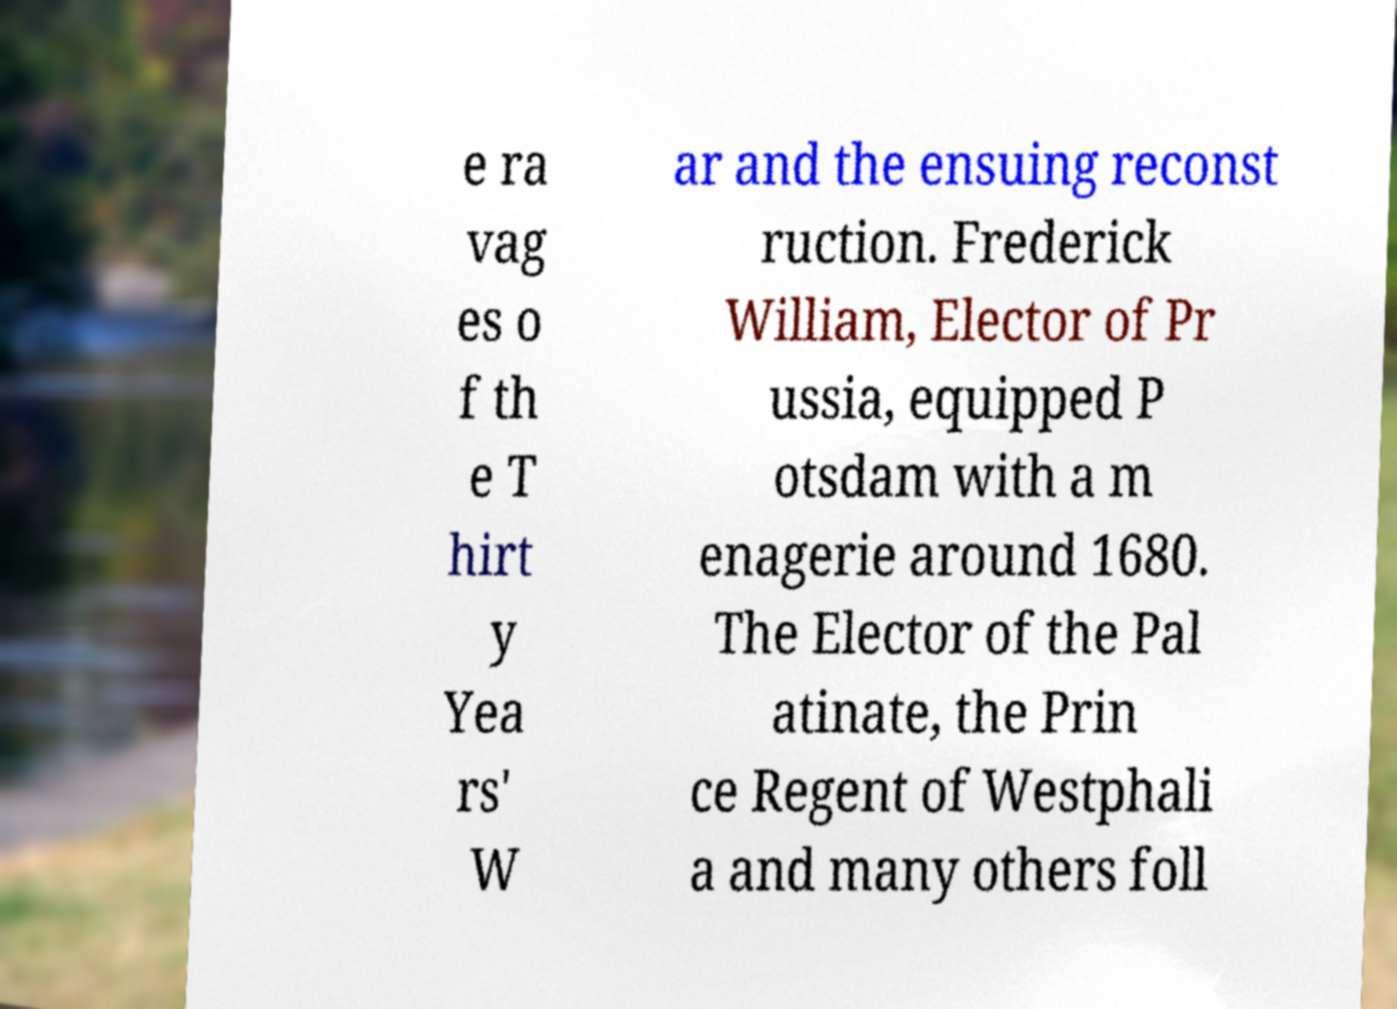What messages or text are displayed in this image? I need them in a readable, typed format. e ra vag es o f th e T hirt y Yea rs' W ar and the ensuing reconst ruction. Frederick William, Elector of Pr ussia, equipped P otsdam with a m enagerie around 1680. The Elector of the Pal atinate, the Prin ce Regent of Westphali a and many others foll 